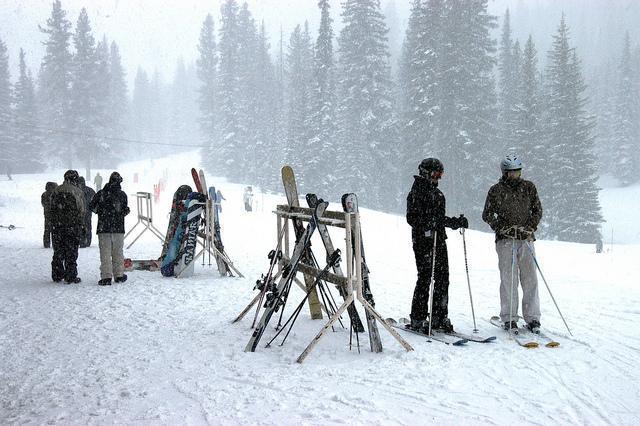What could potentially impede their vision shortly?
Choose the right answer from the provided options to respond to the question.
Options: Snow storm, skiers, goggles, sun. Snow storm. 